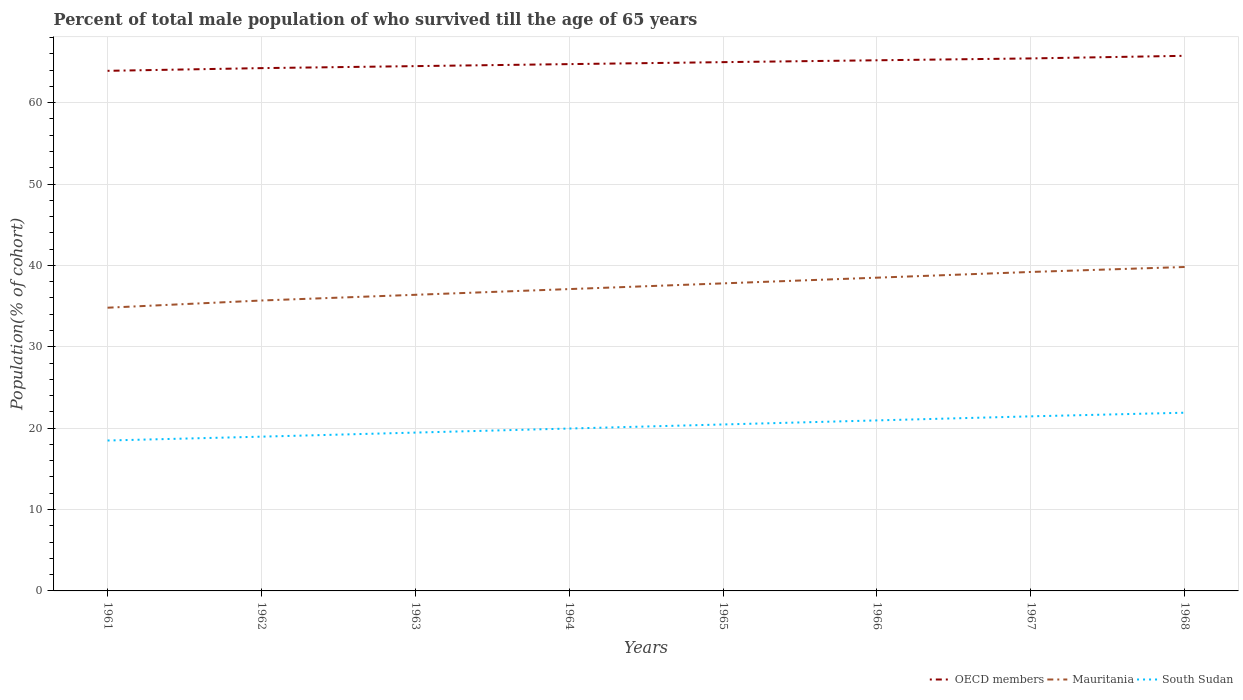How many different coloured lines are there?
Provide a succinct answer. 3. Does the line corresponding to OECD members intersect with the line corresponding to Mauritania?
Provide a short and direct response. No. Across all years, what is the maximum percentage of total male population who survived till the age of 65 years in OECD members?
Your answer should be compact. 63.91. In which year was the percentage of total male population who survived till the age of 65 years in OECD members maximum?
Your answer should be very brief. 1961. What is the total percentage of total male population who survived till the age of 65 years in Mauritania in the graph?
Your response must be concise. -2.1. What is the difference between the highest and the second highest percentage of total male population who survived till the age of 65 years in OECD members?
Make the answer very short. 1.84. What is the difference between the highest and the lowest percentage of total male population who survived till the age of 65 years in Mauritania?
Provide a succinct answer. 4. Is the percentage of total male population who survived till the age of 65 years in Mauritania strictly greater than the percentage of total male population who survived till the age of 65 years in South Sudan over the years?
Keep it short and to the point. No. How many lines are there?
Provide a short and direct response. 3. Are the values on the major ticks of Y-axis written in scientific E-notation?
Provide a succinct answer. No. Does the graph contain grids?
Offer a terse response. Yes. How are the legend labels stacked?
Provide a short and direct response. Horizontal. What is the title of the graph?
Make the answer very short. Percent of total male population of who survived till the age of 65 years. What is the label or title of the X-axis?
Your response must be concise. Years. What is the label or title of the Y-axis?
Provide a short and direct response. Population(% of cohort). What is the Population(% of cohort) of OECD members in 1961?
Offer a very short reply. 63.91. What is the Population(% of cohort) in Mauritania in 1961?
Offer a very short reply. 34.8. What is the Population(% of cohort) in South Sudan in 1961?
Your response must be concise. 18.48. What is the Population(% of cohort) of OECD members in 1962?
Give a very brief answer. 64.24. What is the Population(% of cohort) in Mauritania in 1962?
Your response must be concise. 35.69. What is the Population(% of cohort) of South Sudan in 1962?
Keep it short and to the point. 18.96. What is the Population(% of cohort) in OECD members in 1963?
Offer a very short reply. 64.49. What is the Population(% of cohort) in Mauritania in 1963?
Your response must be concise. 36.39. What is the Population(% of cohort) in South Sudan in 1963?
Offer a terse response. 19.45. What is the Population(% of cohort) in OECD members in 1964?
Offer a terse response. 64.73. What is the Population(% of cohort) in Mauritania in 1964?
Your answer should be compact. 37.09. What is the Population(% of cohort) in South Sudan in 1964?
Provide a short and direct response. 19.95. What is the Population(% of cohort) of OECD members in 1965?
Keep it short and to the point. 64.98. What is the Population(% of cohort) of Mauritania in 1965?
Offer a very short reply. 37.79. What is the Population(% of cohort) in South Sudan in 1965?
Your response must be concise. 20.45. What is the Population(% of cohort) of OECD members in 1966?
Give a very brief answer. 65.2. What is the Population(% of cohort) in Mauritania in 1966?
Your response must be concise. 38.49. What is the Population(% of cohort) in South Sudan in 1966?
Ensure brevity in your answer.  20.95. What is the Population(% of cohort) of OECD members in 1967?
Offer a terse response. 65.43. What is the Population(% of cohort) of Mauritania in 1967?
Give a very brief answer. 39.19. What is the Population(% of cohort) of South Sudan in 1967?
Provide a succinct answer. 21.45. What is the Population(% of cohort) of OECD members in 1968?
Your response must be concise. 65.75. What is the Population(% of cohort) of Mauritania in 1968?
Provide a short and direct response. 39.8. What is the Population(% of cohort) of South Sudan in 1968?
Provide a succinct answer. 21.9. Across all years, what is the maximum Population(% of cohort) in OECD members?
Your answer should be compact. 65.75. Across all years, what is the maximum Population(% of cohort) in Mauritania?
Offer a very short reply. 39.8. Across all years, what is the maximum Population(% of cohort) in South Sudan?
Keep it short and to the point. 21.9. Across all years, what is the minimum Population(% of cohort) of OECD members?
Make the answer very short. 63.91. Across all years, what is the minimum Population(% of cohort) in Mauritania?
Your answer should be very brief. 34.8. Across all years, what is the minimum Population(% of cohort) of South Sudan?
Keep it short and to the point. 18.48. What is the total Population(% of cohort) in OECD members in the graph?
Ensure brevity in your answer.  518.74. What is the total Population(% of cohort) of Mauritania in the graph?
Your response must be concise. 299.25. What is the total Population(% of cohort) of South Sudan in the graph?
Your response must be concise. 161.6. What is the difference between the Population(% of cohort) in OECD members in 1961 and that in 1962?
Offer a very short reply. -0.33. What is the difference between the Population(% of cohort) in Mauritania in 1961 and that in 1962?
Provide a succinct answer. -0.88. What is the difference between the Population(% of cohort) in South Sudan in 1961 and that in 1962?
Provide a succinct answer. -0.47. What is the difference between the Population(% of cohort) of OECD members in 1961 and that in 1963?
Ensure brevity in your answer.  -0.58. What is the difference between the Population(% of cohort) in Mauritania in 1961 and that in 1963?
Provide a succinct answer. -1.59. What is the difference between the Population(% of cohort) of South Sudan in 1961 and that in 1963?
Make the answer very short. -0.97. What is the difference between the Population(% of cohort) in OECD members in 1961 and that in 1964?
Provide a succinct answer. -0.82. What is the difference between the Population(% of cohort) in Mauritania in 1961 and that in 1964?
Your response must be concise. -2.29. What is the difference between the Population(% of cohort) in South Sudan in 1961 and that in 1964?
Offer a terse response. -1.47. What is the difference between the Population(% of cohort) of OECD members in 1961 and that in 1965?
Provide a succinct answer. -1.07. What is the difference between the Population(% of cohort) of Mauritania in 1961 and that in 1965?
Provide a short and direct response. -2.99. What is the difference between the Population(% of cohort) of South Sudan in 1961 and that in 1965?
Ensure brevity in your answer.  -1.97. What is the difference between the Population(% of cohort) of OECD members in 1961 and that in 1966?
Give a very brief answer. -1.3. What is the difference between the Population(% of cohort) of Mauritania in 1961 and that in 1966?
Your response must be concise. -3.69. What is the difference between the Population(% of cohort) in South Sudan in 1961 and that in 1966?
Give a very brief answer. -2.47. What is the difference between the Population(% of cohort) in OECD members in 1961 and that in 1967?
Give a very brief answer. -1.52. What is the difference between the Population(% of cohort) of Mauritania in 1961 and that in 1967?
Offer a very short reply. -4.39. What is the difference between the Population(% of cohort) in South Sudan in 1961 and that in 1967?
Your answer should be very brief. -2.97. What is the difference between the Population(% of cohort) in OECD members in 1961 and that in 1968?
Ensure brevity in your answer.  -1.84. What is the difference between the Population(% of cohort) in Mauritania in 1961 and that in 1968?
Provide a succinct answer. -5. What is the difference between the Population(% of cohort) of South Sudan in 1961 and that in 1968?
Your answer should be compact. -3.42. What is the difference between the Population(% of cohort) in OECD members in 1962 and that in 1963?
Provide a short and direct response. -0.25. What is the difference between the Population(% of cohort) of Mauritania in 1962 and that in 1963?
Ensure brevity in your answer.  -0.7. What is the difference between the Population(% of cohort) of South Sudan in 1962 and that in 1963?
Provide a succinct answer. -0.5. What is the difference between the Population(% of cohort) of OECD members in 1962 and that in 1964?
Your answer should be compact. -0.49. What is the difference between the Population(% of cohort) of Mauritania in 1962 and that in 1964?
Offer a terse response. -1.4. What is the difference between the Population(% of cohort) of South Sudan in 1962 and that in 1964?
Ensure brevity in your answer.  -1. What is the difference between the Population(% of cohort) of OECD members in 1962 and that in 1965?
Keep it short and to the point. -0.73. What is the difference between the Population(% of cohort) in Mauritania in 1962 and that in 1965?
Make the answer very short. -2.1. What is the difference between the Population(% of cohort) in South Sudan in 1962 and that in 1965?
Give a very brief answer. -1.5. What is the difference between the Population(% of cohort) in OECD members in 1962 and that in 1966?
Your answer should be very brief. -0.96. What is the difference between the Population(% of cohort) in Mauritania in 1962 and that in 1966?
Keep it short and to the point. -2.81. What is the difference between the Population(% of cohort) in South Sudan in 1962 and that in 1966?
Your answer should be very brief. -2. What is the difference between the Population(% of cohort) in OECD members in 1962 and that in 1967?
Give a very brief answer. -1.19. What is the difference between the Population(% of cohort) of Mauritania in 1962 and that in 1967?
Keep it short and to the point. -3.51. What is the difference between the Population(% of cohort) in South Sudan in 1962 and that in 1967?
Your answer should be compact. -2.5. What is the difference between the Population(% of cohort) in OECD members in 1962 and that in 1968?
Your answer should be compact. -1.51. What is the difference between the Population(% of cohort) of Mauritania in 1962 and that in 1968?
Provide a succinct answer. -4.12. What is the difference between the Population(% of cohort) of South Sudan in 1962 and that in 1968?
Your response must be concise. -2.94. What is the difference between the Population(% of cohort) in OECD members in 1963 and that in 1964?
Make the answer very short. -0.25. What is the difference between the Population(% of cohort) of Mauritania in 1963 and that in 1964?
Provide a short and direct response. -0.7. What is the difference between the Population(% of cohort) of South Sudan in 1963 and that in 1964?
Your answer should be very brief. -0.5. What is the difference between the Population(% of cohort) of OECD members in 1963 and that in 1965?
Ensure brevity in your answer.  -0.49. What is the difference between the Population(% of cohort) of Mauritania in 1963 and that in 1965?
Give a very brief answer. -1.4. What is the difference between the Population(% of cohort) of South Sudan in 1963 and that in 1965?
Offer a very short reply. -1. What is the difference between the Population(% of cohort) of OECD members in 1963 and that in 1966?
Your response must be concise. -0.72. What is the difference between the Population(% of cohort) of Mauritania in 1963 and that in 1966?
Your answer should be very brief. -2.1. What is the difference between the Population(% of cohort) in South Sudan in 1963 and that in 1966?
Your answer should be compact. -1.5. What is the difference between the Population(% of cohort) of OECD members in 1963 and that in 1967?
Give a very brief answer. -0.95. What is the difference between the Population(% of cohort) in Mauritania in 1963 and that in 1967?
Provide a short and direct response. -2.81. What is the difference between the Population(% of cohort) of South Sudan in 1963 and that in 1967?
Your answer should be compact. -2. What is the difference between the Population(% of cohort) of OECD members in 1963 and that in 1968?
Provide a short and direct response. -1.27. What is the difference between the Population(% of cohort) in Mauritania in 1963 and that in 1968?
Keep it short and to the point. -3.42. What is the difference between the Population(% of cohort) of South Sudan in 1963 and that in 1968?
Your response must be concise. -2.44. What is the difference between the Population(% of cohort) of OECD members in 1964 and that in 1965?
Give a very brief answer. -0.24. What is the difference between the Population(% of cohort) in Mauritania in 1964 and that in 1965?
Ensure brevity in your answer.  -0.7. What is the difference between the Population(% of cohort) in South Sudan in 1964 and that in 1965?
Give a very brief answer. -0.5. What is the difference between the Population(% of cohort) in OECD members in 1964 and that in 1966?
Your answer should be very brief. -0.47. What is the difference between the Population(% of cohort) in Mauritania in 1964 and that in 1966?
Provide a short and direct response. -1.4. What is the difference between the Population(% of cohort) of South Sudan in 1964 and that in 1966?
Provide a succinct answer. -1. What is the difference between the Population(% of cohort) in Mauritania in 1964 and that in 1967?
Offer a terse response. -2.1. What is the difference between the Population(% of cohort) in South Sudan in 1964 and that in 1967?
Your answer should be very brief. -1.5. What is the difference between the Population(% of cohort) of OECD members in 1964 and that in 1968?
Offer a very short reply. -1.02. What is the difference between the Population(% of cohort) of Mauritania in 1964 and that in 1968?
Provide a short and direct response. -2.71. What is the difference between the Population(% of cohort) of South Sudan in 1964 and that in 1968?
Ensure brevity in your answer.  -1.94. What is the difference between the Population(% of cohort) in OECD members in 1965 and that in 1966?
Keep it short and to the point. -0.23. What is the difference between the Population(% of cohort) in Mauritania in 1965 and that in 1966?
Ensure brevity in your answer.  -0.7. What is the difference between the Population(% of cohort) of South Sudan in 1965 and that in 1966?
Your answer should be compact. -0.5. What is the difference between the Population(% of cohort) of OECD members in 1965 and that in 1967?
Offer a terse response. -0.46. What is the difference between the Population(% of cohort) of Mauritania in 1965 and that in 1967?
Provide a succinct answer. -1.4. What is the difference between the Population(% of cohort) of South Sudan in 1965 and that in 1967?
Offer a terse response. -1. What is the difference between the Population(% of cohort) in OECD members in 1965 and that in 1968?
Your answer should be compact. -0.78. What is the difference between the Population(% of cohort) of Mauritania in 1965 and that in 1968?
Give a very brief answer. -2.01. What is the difference between the Population(% of cohort) in South Sudan in 1965 and that in 1968?
Keep it short and to the point. -1.44. What is the difference between the Population(% of cohort) of OECD members in 1966 and that in 1967?
Make the answer very short. -0.23. What is the difference between the Population(% of cohort) of Mauritania in 1966 and that in 1967?
Give a very brief answer. -0.7. What is the difference between the Population(% of cohort) of South Sudan in 1966 and that in 1967?
Make the answer very short. -0.5. What is the difference between the Population(% of cohort) in OECD members in 1966 and that in 1968?
Provide a succinct answer. -0.55. What is the difference between the Population(% of cohort) of Mauritania in 1966 and that in 1968?
Keep it short and to the point. -1.31. What is the difference between the Population(% of cohort) in South Sudan in 1966 and that in 1968?
Provide a short and direct response. -0.94. What is the difference between the Population(% of cohort) of OECD members in 1967 and that in 1968?
Give a very brief answer. -0.32. What is the difference between the Population(% of cohort) of Mauritania in 1967 and that in 1968?
Provide a short and direct response. -0.61. What is the difference between the Population(% of cohort) in South Sudan in 1967 and that in 1968?
Offer a very short reply. -0.45. What is the difference between the Population(% of cohort) of OECD members in 1961 and the Population(% of cohort) of Mauritania in 1962?
Give a very brief answer. 28.22. What is the difference between the Population(% of cohort) in OECD members in 1961 and the Population(% of cohort) in South Sudan in 1962?
Provide a short and direct response. 44.95. What is the difference between the Population(% of cohort) in Mauritania in 1961 and the Population(% of cohort) in South Sudan in 1962?
Offer a terse response. 15.85. What is the difference between the Population(% of cohort) in OECD members in 1961 and the Population(% of cohort) in Mauritania in 1963?
Provide a short and direct response. 27.52. What is the difference between the Population(% of cohort) of OECD members in 1961 and the Population(% of cohort) of South Sudan in 1963?
Provide a short and direct response. 44.45. What is the difference between the Population(% of cohort) of Mauritania in 1961 and the Population(% of cohort) of South Sudan in 1963?
Keep it short and to the point. 15.35. What is the difference between the Population(% of cohort) in OECD members in 1961 and the Population(% of cohort) in Mauritania in 1964?
Ensure brevity in your answer.  26.82. What is the difference between the Population(% of cohort) of OECD members in 1961 and the Population(% of cohort) of South Sudan in 1964?
Provide a short and direct response. 43.95. What is the difference between the Population(% of cohort) in Mauritania in 1961 and the Population(% of cohort) in South Sudan in 1964?
Offer a very short reply. 14.85. What is the difference between the Population(% of cohort) in OECD members in 1961 and the Population(% of cohort) in Mauritania in 1965?
Offer a terse response. 26.12. What is the difference between the Population(% of cohort) in OECD members in 1961 and the Population(% of cohort) in South Sudan in 1965?
Your response must be concise. 43.46. What is the difference between the Population(% of cohort) of Mauritania in 1961 and the Population(% of cohort) of South Sudan in 1965?
Keep it short and to the point. 14.35. What is the difference between the Population(% of cohort) in OECD members in 1961 and the Population(% of cohort) in Mauritania in 1966?
Provide a short and direct response. 25.42. What is the difference between the Population(% of cohort) in OECD members in 1961 and the Population(% of cohort) in South Sudan in 1966?
Provide a succinct answer. 42.96. What is the difference between the Population(% of cohort) in Mauritania in 1961 and the Population(% of cohort) in South Sudan in 1966?
Give a very brief answer. 13.85. What is the difference between the Population(% of cohort) in OECD members in 1961 and the Population(% of cohort) in Mauritania in 1967?
Give a very brief answer. 24.72. What is the difference between the Population(% of cohort) of OECD members in 1961 and the Population(% of cohort) of South Sudan in 1967?
Provide a short and direct response. 42.46. What is the difference between the Population(% of cohort) of Mauritania in 1961 and the Population(% of cohort) of South Sudan in 1967?
Ensure brevity in your answer.  13.35. What is the difference between the Population(% of cohort) of OECD members in 1961 and the Population(% of cohort) of Mauritania in 1968?
Keep it short and to the point. 24.1. What is the difference between the Population(% of cohort) of OECD members in 1961 and the Population(% of cohort) of South Sudan in 1968?
Your response must be concise. 42.01. What is the difference between the Population(% of cohort) in Mauritania in 1961 and the Population(% of cohort) in South Sudan in 1968?
Provide a succinct answer. 12.9. What is the difference between the Population(% of cohort) in OECD members in 1962 and the Population(% of cohort) in Mauritania in 1963?
Offer a very short reply. 27.85. What is the difference between the Population(% of cohort) in OECD members in 1962 and the Population(% of cohort) in South Sudan in 1963?
Your answer should be very brief. 44.79. What is the difference between the Population(% of cohort) of Mauritania in 1962 and the Population(% of cohort) of South Sudan in 1963?
Ensure brevity in your answer.  16.23. What is the difference between the Population(% of cohort) in OECD members in 1962 and the Population(% of cohort) in Mauritania in 1964?
Ensure brevity in your answer.  27.15. What is the difference between the Population(% of cohort) in OECD members in 1962 and the Population(% of cohort) in South Sudan in 1964?
Make the answer very short. 44.29. What is the difference between the Population(% of cohort) of Mauritania in 1962 and the Population(% of cohort) of South Sudan in 1964?
Offer a very short reply. 15.73. What is the difference between the Population(% of cohort) in OECD members in 1962 and the Population(% of cohort) in Mauritania in 1965?
Offer a terse response. 26.45. What is the difference between the Population(% of cohort) of OECD members in 1962 and the Population(% of cohort) of South Sudan in 1965?
Your response must be concise. 43.79. What is the difference between the Population(% of cohort) in Mauritania in 1962 and the Population(% of cohort) in South Sudan in 1965?
Provide a short and direct response. 15.23. What is the difference between the Population(% of cohort) of OECD members in 1962 and the Population(% of cohort) of Mauritania in 1966?
Provide a succinct answer. 25.75. What is the difference between the Population(% of cohort) of OECD members in 1962 and the Population(% of cohort) of South Sudan in 1966?
Make the answer very short. 43.29. What is the difference between the Population(% of cohort) in Mauritania in 1962 and the Population(% of cohort) in South Sudan in 1966?
Provide a short and direct response. 14.73. What is the difference between the Population(% of cohort) of OECD members in 1962 and the Population(% of cohort) of Mauritania in 1967?
Provide a short and direct response. 25.05. What is the difference between the Population(% of cohort) in OECD members in 1962 and the Population(% of cohort) in South Sudan in 1967?
Offer a terse response. 42.79. What is the difference between the Population(% of cohort) of Mauritania in 1962 and the Population(% of cohort) of South Sudan in 1967?
Offer a very short reply. 14.23. What is the difference between the Population(% of cohort) of OECD members in 1962 and the Population(% of cohort) of Mauritania in 1968?
Provide a succinct answer. 24.44. What is the difference between the Population(% of cohort) of OECD members in 1962 and the Population(% of cohort) of South Sudan in 1968?
Give a very brief answer. 42.34. What is the difference between the Population(% of cohort) of Mauritania in 1962 and the Population(% of cohort) of South Sudan in 1968?
Offer a very short reply. 13.79. What is the difference between the Population(% of cohort) of OECD members in 1963 and the Population(% of cohort) of Mauritania in 1964?
Keep it short and to the point. 27.4. What is the difference between the Population(% of cohort) in OECD members in 1963 and the Population(% of cohort) in South Sudan in 1964?
Provide a short and direct response. 44.53. What is the difference between the Population(% of cohort) in Mauritania in 1963 and the Population(% of cohort) in South Sudan in 1964?
Give a very brief answer. 16.43. What is the difference between the Population(% of cohort) in OECD members in 1963 and the Population(% of cohort) in Mauritania in 1965?
Ensure brevity in your answer.  26.7. What is the difference between the Population(% of cohort) of OECD members in 1963 and the Population(% of cohort) of South Sudan in 1965?
Offer a very short reply. 44.03. What is the difference between the Population(% of cohort) of Mauritania in 1963 and the Population(% of cohort) of South Sudan in 1965?
Your answer should be compact. 15.93. What is the difference between the Population(% of cohort) in OECD members in 1963 and the Population(% of cohort) in Mauritania in 1966?
Offer a very short reply. 25.99. What is the difference between the Population(% of cohort) in OECD members in 1963 and the Population(% of cohort) in South Sudan in 1966?
Your answer should be very brief. 43.53. What is the difference between the Population(% of cohort) of Mauritania in 1963 and the Population(% of cohort) of South Sudan in 1966?
Your response must be concise. 15.44. What is the difference between the Population(% of cohort) of OECD members in 1963 and the Population(% of cohort) of Mauritania in 1967?
Make the answer very short. 25.29. What is the difference between the Population(% of cohort) of OECD members in 1963 and the Population(% of cohort) of South Sudan in 1967?
Make the answer very short. 43.03. What is the difference between the Population(% of cohort) in Mauritania in 1963 and the Population(% of cohort) in South Sudan in 1967?
Your answer should be very brief. 14.94. What is the difference between the Population(% of cohort) of OECD members in 1963 and the Population(% of cohort) of Mauritania in 1968?
Provide a short and direct response. 24.68. What is the difference between the Population(% of cohort) of OECD members in 1963 and the Population(% of cohort) of South Sudan in 1968?
Give a very brief answer. 42.59. What is the difference between the Population(% of cohort) of Mauritania in 1963 and the Population(% of cohort) of South Sudan in 1968?
Offer a terse response. 14.49. What is the difference between the Population(% of cohort) in OECD members in 1964 and the Population(% of cohort) in Mauritania in 1965?
Your answer should be very brief. 26.94. What is the difference between the Population(% of cohort) of OECD members in 1964 and the Population(% of cohort) of South Sudan in 1965?
Your answer should be very brief. 44.28. What is the difference between the Population(% of cohort) in Mauritania in 1964 and the Population(% of cohort) in South Sudan in 1965?
Give a very brief answer. 16.64. What is the difference between the Population(% of cohort) in OECD members in 1964 and the Population(% of cohort) in Mauritania in 1966?
Offer a terse response. 26.24. What is the difference between the Population(% of cohort) of OECD members in 1964 and the Population(% of cohort) of South Sudan in 1966?
Provide a succinct answer. 43.78. What is the difference between the Population(% of cohort) of Mauritania in 1964 and the Population(% of cohort) of South Sudan in 1966?
Your answer should be compact. 16.14. What is the difference between the Population(% of cohort) of OECD members in 1964 and the Population(% of cohort) of Mauritania in 1967?
Offer a terse response. 25.54. What is the difference between the Population(% of cohort) of OECD members in 1964 and the Population(% of cohort) of South Sudan in 1967?
Make the answer very short. 43.28. What is the difference between the Population(% of cohort) of Mauritania in 1964 and the Population(% of cohort) of South Sudan in 1967?
Ensure brevity in your answer.  15.64. What is the difference between the Population(% of cohort) of OECD members in 1964 and the Population(% of cohort) of Mauritania in 1968?
Make the answer very short. 24.93. What is the difference between the Population(% of cohort) of OECD members in 1964 and the Population(% of cohort) of South Sudan in 1968?
Offer a terse response. 42.84. What is the difference between the Population(% of cohort) in Mauritania in 1964 and the Population(% of cohort) in South Sudan in 1968?
Ensure brevity in your answer.  15.19. What is the difference between the Population(% of cohort) of OECD members in 1965 and the Population(% of cohort) of Mauritania in 1966?
Make the answer very short. 26.48. What is the difference between the Population(% of cohort) of OECD members in 1965 and the Population(% of cohort) of South Sudan in 1966?
Make the answer very short. 44.02. What is the difference between the Population(% of cohort) of Mauritania in 1965 and the Population(% of cohort) of South Sudan in 1966?
Your answer should be compact. 16.84. What is the difference between the Population(% of cohort) of OECD members in 1965 and the Population(% of cohort) of Mauritania in 1967?
Your answer should be compact. 25.78. What is the difference between the Population(% of cohort) of OECD members in 1965 and the Population(% of cohort) of South Sudan in 1967?
Provide a short and direct response. 43.52. What is the difference between the Population(% of cohort) of Mauritania in 1965 and the Population(% of cohort) of South Sudan in 1967?
Keep it short and to the point. 16.34. What is the difference between the Population(% of cohort) in OECD members in 1965 and the Population(% of cohort) in Mauritania in 1968?
Give a very brief answer. 25.17. What is the difference between the Population(% of cohort) in OECD members in 1965 and the Population(% of cohort) in South Sudan in 1968?
Offer a very short reply. 43.08. What is the difference between the Population(% of cohort) of Mauritania in 1965 and the Population(% of cohort) of South Sudan in 1968?
Offer a terse response. 15.89. What is the difference between the Population(% of cohort) in OECD members in 1966 and the Population(% of cohort) in Mauritania in 1967?
Your answer should be compact. 26.01. What is the difference between the Population(% of cohort) in OECD members in 1966 and the Population(% of cohort) in South Sudan in 1967?
Your response must be concise. 43.75. What is the difference between the Population(% of cohort) in Mauritania in 1966 and the Population(% of cohort) in South Sudan in 1967?
Your response must be concise. 17.04. What is the difference between the Population(% of cohort) of OECD members in 1966 and the Population(% of cohort) of Mauritania in 1968?
Keep it short and to the point. 25.4. What is the difference between the Population(% of cohort) in OECD members in 1966 and the Population(% of cohort) in South Sudan in 1968?
Offer a very short reply. 43.31. What is the difference between the Population(% of cohort) of Mauritania in 1966 and the Population(% of cohort) of South Sudan in 1968?
Provide a short and direct response. 16.59. What is the difference between the Population(% of cohort) in OECD members in 1967 and the Population(% of cohort) in Mauritania in 1968?
Your response must be concise. 25.63. What is the difference between the Population(% of cohort) of OECD members in 1967 and the Population(% of cohort) of South Sudan in 1968?
Ensure brevity in your answer.  43.54. What is the difference between the Population(% of cohort) in Mauritania in 1967 and the Population(% of cohort) in South Sudan in 1968?
Provide a short and direct response. 17.3. What is the average Population(% of cohort) of OECD members per year?
Offer a very short reply. 64.84. What is the average Population(% of cohort) in Mauritania per year?
Give a very brief answer. 37.41. What is the average Population(% of cohort) in South Sudan per year?
Make the answer very short. 20.2. In the year 1961, what is the difference between the Population(% of cohort) in OECD members and Population(% of cohort) in Mauritania?
Offer a terse response. 29.11. In the year 1961, what is the difference between the Population(% of cohort) in OECD members and Population(% of cohort) in South Sudan?
Offer a terse response. 45.43. In the year 1961, what is the difference between the Population(% of cohort) in Mauritania and Population(% of cohort) in South Sudan?
Offer a terse response. 16.32. In the year 1962, what is the difference between the Population(% of cohort) of OECD members and Population(% of cohort) of Mauritania?
Your answer should be very brief. 28.55. In the year 1962, what is the difference between the Population(% of cohort) of OECD members and Population(% of cohort) of South Sudan?
Your answer should be very brief. 45.29. In the year 1962, what is the difference between the Population(% of cohort) of Mauritania and Population(% of cohort) of South Sudan?
Give a very brief answer. 16.73. In the year 1963, what is the difference between the Population(% of cohort) in OECD members and Population(% of cohort) in Mauritania?
Offer a very short reply. 28.1. In the year 1963, what is the difference between the Population(% of cohort) of OECD members and Population(% of cohort) of South Sudan?
Keep it short and to the point. 45.03. In the year 1963, what is the difference between the Population(% of cohort) in Mauritania and Population(% of cohort) in South Sudan?
Provide a succinct answer. 16.93. In the year 1964, what is the difference between the Population(% of cohort) in OECD members and Population(% of cohort) in Mauritania?
Keep it short and to the point. 27.64. In the year 1964, what is the difference between the Population(% of cohort) in OECD members and Population(% of cohort) in South Sudan?
Make the answer very short. 44.78. In the year 1964, what is the difference between the Population(% of cohort) of Mauritania and Population(% of cohort) of South Sudan?
Give a very brief answer. 17.14. In the year 1965, what is the difference between the Population(% of cohort) in OECD members and Population(% of cohort) in Mauritania?
Offer a very short reply. 27.18. In the year 1965, what is the difference between the Population(% of cohort) in OECD members and Population(% of cohort) in South Sudan?
Provide a short and direct response. 44.52. In the year 1965, what is the difference between the Population(% of cohort) in Mauritania and Population(% of cohort) in South Sudan?
Your answer should be compact. 17.34. In the year 1966, what is the difference between the Population(% of cohort) of OECD members and Population(% of cohort) of Mauritania?
Your answer should be very brief. 26.71. In the year 1966, what is the difference between the Population(% of cohort) of OECD members and Population(% of cohort) of South Sudan?
Ensure brevity in your answer.  44.25. In the year 1966, what is the difference between the Population(% of cohort) in Mauritania and Population(% of cohort) in South Sudan?
Your response must be concise. 17.54. In the year 1967, what is the difference between the Population(% of cohort) of OECD members and Population(% of cohort) of Mauritania?
Keep it short and to the point. 26.24. In the year 1967, what is the difference between the Population(% of cohort) in OECD members and Population(% of cohort) in South Sudan?
Make the answer very short. 43.98. In the year 1967, what is the difference between the Population(% of cohort) in Mauritania and Population(% of cohort) in South Sudan?
Your answer should be compact. 17.74. In the year 1968, what is the difference between the Population(% of cohort) of OECD members and Population(% of cohort) of Mauritania?
Your answer should be compact. 25.95. In the year 1968, what is the difference between the Population(% of cohort) of OECD members and Population(% of cohort) of South Sudan?
Provide a succinct answer. 43.86. In the year 1968, what is the difference between the Population(% of cohort) in Mauritania and Population(% of cohort) in South Sudan?
Give a very brief answer. 17.91. What is the ratio of the Population(% of cohort) in Mauritania in 1961 to that in 1962?
Your response must be concise. 0.98. What is the ratio of the Population(% of cohort) of South Sudan in 1961 to that in 1962?
Give a very brief answer. 0.97. What is the ratio of the Population(% of cohort) of Mauritania in 1961 to that in 1963?
Make the answer very short. 0.96. What is the ratio of the Population(% of cohort) in OECD members in 1961 to that in 1964?
Provide a short and direct response. 0.99. What is the ratio of the Population(% of cohort) of Mauritania in 1961 to that in 1964?
Give a very brief answer. 0.94. What is the ratio of the Population(% of cohort) in South Sudan in 1961 to that in 1964?
Make the answer very short. 0.93. What is the ratio of the Population(% of cohort) in OECD members in 1961 to that in 1965?
Your answer should be compact. 0.98. What is the ratio of the Population(% of cohort) of Mauritania in 1961 to that in 1965?
Your response must be concise. 0.92. What is the ratio of the Population(% of cohort) of South Sudan in 1961 to that in 1965?
Your answer should be compact. 0.9. What is the ratio of the Population(% of cohort) of OECD members in 1961 to that in 1966?
Your answer should be compact. 0.98. What is the ratio of the Population(% of cohort) in Mauritania in 1961 to that in 1966?
Give a very brief answer. 0.9. What is the ratio of the Population(% of cohort) in South Sudan in 1961 to that in 1966?
Offer a very short reply. 0.88. What is the ratio of the Population(% of cohort) of OECD members in 1961 to that in 1967?
Ensure brevity in your answer.  0.98. What is the ratio of the Population(% of cohort) in Mauritania in 1961 to that in 1967?
Your response must be concise. 0.89. What is the ratio of the Population(% of cohort) of South Sudan in 1961 to that in 1967?
Keep it short and to the point. 0.86. What is the ratio of the Population(% of cohort) in OECD members in 1961 to that in 1968?
Provide a short and direct response. 0.97. What is the ratio of the Population(% of cohort) of Mauritania in 1961 to that in 1968?
Your answer should be very brief. 0.87. What is the ratio of the Population(% of cohort) in South Sudan in 1961 to that in 1968?
Give a very brief answer. 0.84. What is the ratio of the Population(% of cohort) in OECD members in 1962 to that in 1963?
Keep it short and to the point. 1. What is the ratio of the Population(% of cohort) of Mauritania in 1962 to that in 1963?
Keep it short and to the point. 0.98. What is the ratio of the Population(% of cohort) of South Sudan in 1962 to that in 1963?
Provide a short and direct response. 0.97. What is the ratio of the Population(% of cohort) in OECD members in 1962 to that in 1964?
Offer a very short reply. 0.99. What is the ratio of the Population(% of cohort) in Mauritania in 1962 to that in 1964?
Provide a short and direct response. 0.96. What is the ratio of the Population(% of cohort) of OECD members in 1962 to that in 1965?
Make the answer very short. 0.99. What is the ratio of the Population(% of cohort) in Mauritania in 1962 to that in 1965?
Provide a short and direct response. 0.94. What is the ratio of the Population(% of cohort) in South Sudan in 1962 to that in 1965?
Ensure brevity in your answer.  0.93. What is the ratio of the Population(% of cohort) of OECD members in 1962 to that in 1966?
Your answer should be very brief. 0.99. What is the ratio of the Population(% of cohort) in Mauritania in 1962 to that in 1966?
Ensure brevity in your answer.  0.93. What is the ratio of the Population(% of cohort) in South Sudan in 1962 to that in 1966?
Offer a terse response. 0.9. What is the ratio of the Population(% of cohort) of OECD members in 1962 to that in 1967?
Your answer should be compact. 0.98. What is the ratio of the Population(% of cohort) of Mauritania in 1962 to that in 1967?
Offer a terse response. 0.91. What is the ratio of the Population(% of cohort) of South Sudan in 1962 to that in 1967?
Give a very brief answer. 0.88. What is the ratio of the Population(% of cohort) of OECD members in 1962 to that in 1968?
Keep it short and to the point. 0.98. What is the ratio of the Population(% of cohort) in Mauritania in 1962 to that in 1968?
Keep it short and to the point. 0.9. What is the ratio of the Population(% of cohort) of South Sudan in 1962 to that in 1968?
Your answer should be very brief. 0.87. What is the ratio of the Population(% of cohort) in Mauritania in 1963 to that in 1964?
Your answer should be very brief. 0.98. What is the ratio of the Population(% of cohort) of South Sudan in 1963 to that in 1964?
Offer a terse response. 0.97. What is the ratio of the Population(% of cohort) in OECD members in 1963 to that in 1965?
Give a very brief answer. 0.99. What is the ratio of the Population(% of cohort) in Mauritania in 1963 to that in 1965?
Ensure brevity in your answer.  0.96. What is the ratio of the Population(% of cohort) of South Sudan in 1963 to that in 1965?
Provide a succinct answer. 0.95. What is the ratio of the Population(% of cohort) in OECD members in 1963 to that in 1966?
Your answer should be compact. 0.99. What is the ratio of the Population(% of cohort) of Mauritania in 1963 to that in 1966?
Provide a succinct answer. 0.95. What is the ratio of the Population(% of cohort) of South Sudan in 1963 to that in 1966?
Offer a terse response. 0.93. What is the ratio of the Population(% of cohort) of OECD members in 1963 to that in 1967?
Offer a very short reply. 0.99. What is the ratio of the Population(% of cohort) in Mauritania in 1963 to that in 1967?
Offer a terse response. 0.93. What is the ratio of the Population(% of cohort) of South Sudan in 1963 to that in 1967?
Keep it short and to the point. 0.91. What is the ratio of the Population(% of cohort) in OECD members in 1963 to that in 1968?
Ensure brevity in your answer.  0.98. What is the ratio of the Population(% of cohort) in Mauritania in 1963 to that in 1968?
Your response must be concise. 0.91. What is the ratio of the Population(% of cohort) of South Sudan in 1963 to that in 1968?
Offer a terse response. 0.89. What is the ratio of the Population(% of cohort) of Mauritania in 1964 to that in 1965?
Offer a very short reply. 0.98. What is the ratio of the Population(% of cohort) in South Sudan in 1964 to that in 1965?
Offer a very short reply. 0.98. What is the ratio of the Population(% of cohort) of Mauritania in 1964 to that in 1966?
Keep it short and to the point. 0.96. What is the ratio of the Population(% of cohort) of South Sudan in 1964 to that in 1966?
Provide a short and direct response. 0.95. What is the ratio of the Population(% of cohort) in OECD members in 1964 to that in 1967?
Provide a short and direct response. 0.99. What is the ratio of the Population(% of cohort) of Mauritania in 1964 to that in 1967?
Make the answer very short. 0.95. What is the ratio of the Population(% of cohort) of South Sudan in 1964 to that in 1967?
Keep it short and to the point. 0.93. What is the ratio of the Population(% of cohort) of OECD members in 1964 to that in 1968?
Ensure brevity in your answer.  0.98. What is the ratio of the Population(% of cohort) of Mauritania in 1964 to that in 1968?
Provide a short and direct response. 0.93. What is the ratio of the Population(% of cohort) of South Sudan in 1964 to that in 1968?
Offer a very short reply. 0.91. What is the ratio of the Population(% of cohort) in OECD members in 1965 to that in 1966?
Offer a terse response. 1. What is the ratio of the Population(% of cohort) in Mauritania in 1965 to that in 1966?
Offer a very short reply. 0.98. What is the ratio of the Population(% of cohort) in South Sudan in 1965 to that in 1966?
Your response must be concise. 0.98. What is the ratio of the Population(% of cohort) of Mauritania in 1965 to that in 1967?
Give a very brief answer. 0.96. What is the ratio of the Population(% of cohort) in South Sudan in 1965 to that in 1967?
Your response must be concise. 0.95. What is the ratio of the Population(% of cohort) of Mauritania in 1965 to that in 1968?
Provide a short and direct response. 0.95. What is the ratio of the Population(% of cohort) in South Sudan in 1965 to that in 1968?
Your answer should be very brief. 0.93. What is the ratio of the Population(% of cohort) in OECD members in 1966 to that in 1967?
Your answer should be compact. 1. What is the ratio of the Population(% of cohort) in Mauritania in 1966 to that in 1967?
Provide a short and direct response. 0.98. What is the ratio of the Population(% of cohort) in South Sudan in 1966 to that in 1967?
Make the answer very short. 0.98. What is the ratio of the Population(% of cohort) of South Sudan in 1966 to that in 1968?
Give a very brief answer. 0.96. What is the ratio of the Population(% of cohort) in OECD members in 1967 to that in 1968?
Ensure brevity in your answer.  1. What is the ratio of the Population(% of cohort) in Mauritania in 1967 to that in 1968?
Provide a short and direct response. 0.98. What is the ratio of the Population(% of cohort) of South Sudan in 1967 to that in 1968?
Make the answer very short. 0.98. What is the difference between the highest and the second highest Population(% of cohort) in OECD members?
Give a very brief answer. 0.32. What is the difference between the highest and the second highest Population(% of cohort) of Mauritania?
Offer a very short reply. 0.61. What is the difference between the highest and the second highest Population(% of cohort) in South Sudan?
Give a very brief answer. 0.45. What is the difference between the highest and the lowest Population(% of cohort) of OECD members?
Your answer should be very brief. 1.84. What is the difference between the highest and the lowest Population(% of cohort) in Mauritania?
Your response must be concise. 5. What is the difference between the highest and the lowest Population(% of cohort) of South Sudan?
Your response must be concise. 3.42. 